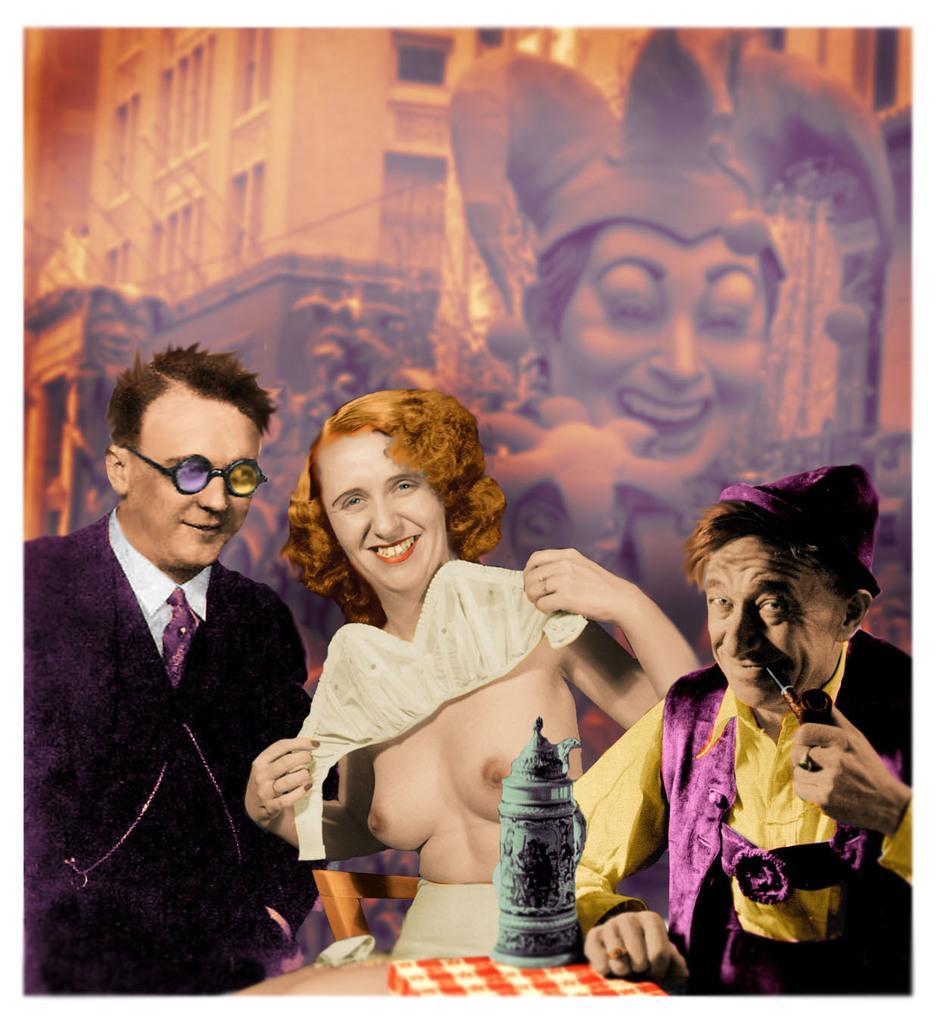Could you give a brief overview of what you see in this image? In this image we can see a lady and two men. Man on the right side is holding a pipe. Near to him there is a box and an object. On the left side there is a man wearing specs. In the back there is a wall with a buildings and some other things. 